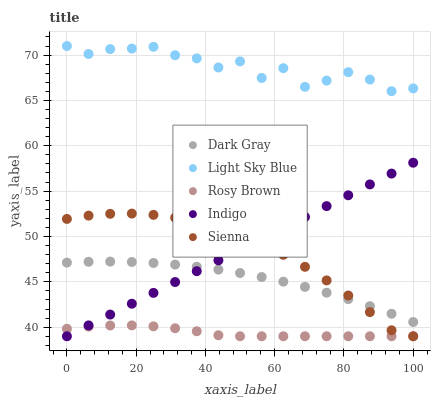Does Rosy Brown have the minimum area under the curve?
Answer yes or no. Yes. Does Light Sky Blue have the maximum area under the curve?
Answer yes or no. Yes. Does Sienna have the minimum area under the curve?
Answer yes or no. No. Does Sienna have the maximum area under the curve?
Answer yes or no. No. Is Indigo the smoothest?
Answer yes or no. Yes. Is Light Sky Blue the roughest?
Answer yes or no. Yes. Is Sienna the smoothest?
Answer yes or no. No. Is Sienna the roughest?
Answer yes or no. No. Does Sienna have the lowest value?
Answer yes or no. Yes. Does Light Sky Blue have the lowest value?
Answer yes or no. No. Does Light Sky Blue have the highest value?
Answer yes or no. Yes. Does Sienna have the highest value?
Answer yes or no. No. Is Sienna less than Light Sky Blue?
Answer yes or no. Yes. Is Light Sky Blue greater than Dark Gray?
Answer yes or no. Yes. Does Sienna intersect Rosy Brown?
Answer yes or no. Yes. Is Sienna less than Rosy Brown?
Answer yes or no. No. Is Sienna greater than Rosy Brown?
Answer yes or no. No. Does Sienna intersect Light Sky Blue?
Answer yes or no. No. 